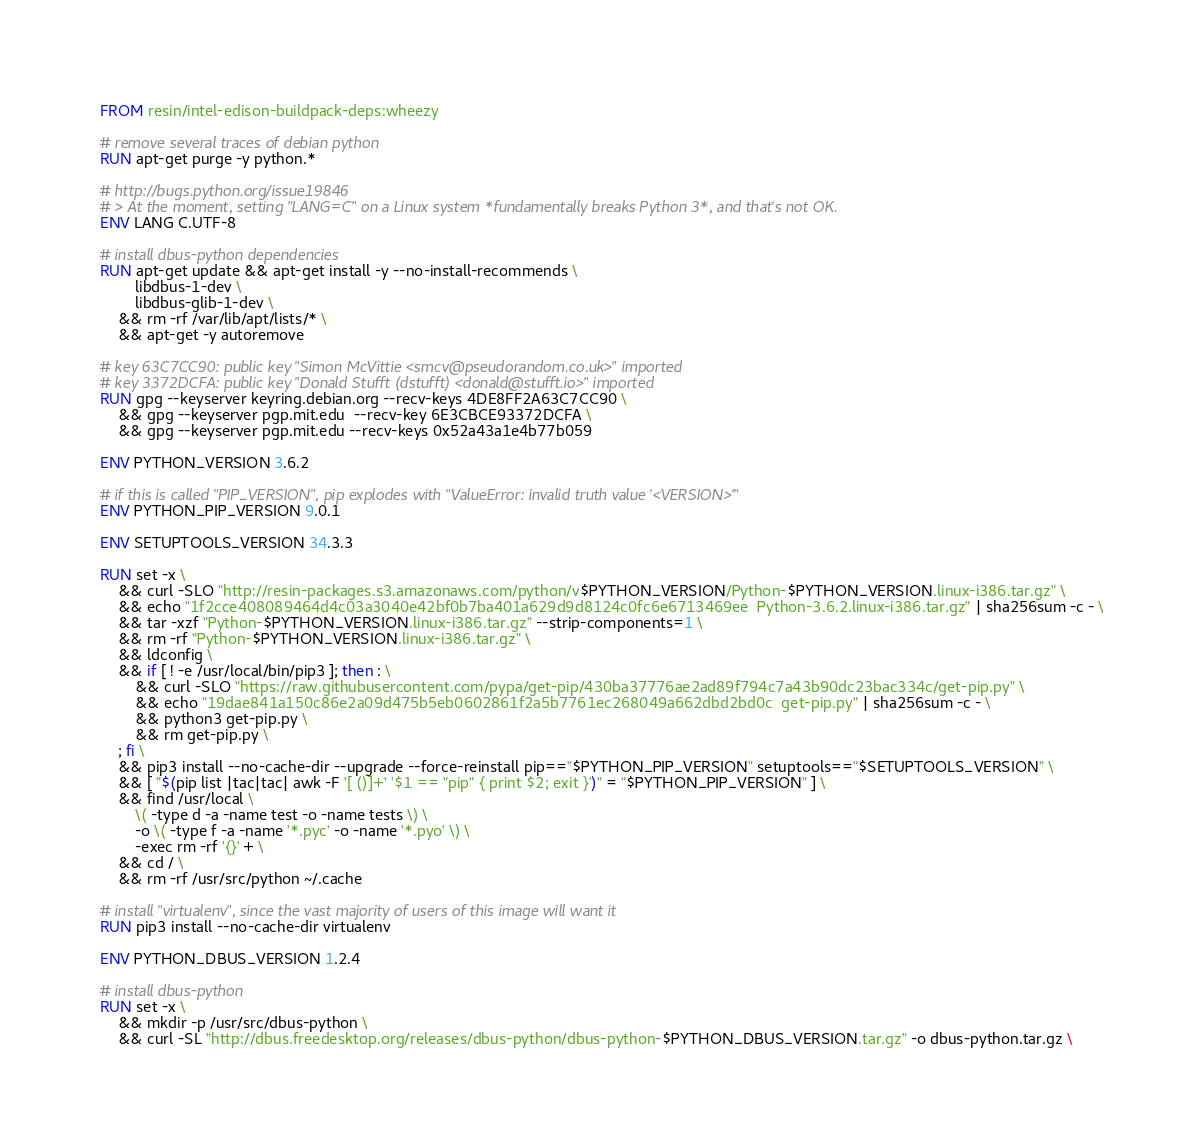<code> <loc_0><loc_0><loc_500><loc_500><_Dockerfile_>FROM resin/intel-edison-buildpack-deps:wheezy

# remove several traces of debian python
RUN apt-get purge -y python.*

# http://bugs.python.org/issue19846
# > At the moment, setting "LANG=C" on a Linux system *fundamentally breaks Python 3*, and that's not OK.
ENV LANG C.UTF-8

# install dbus-python dependencies 
RUN apt-get update && apt-get install -y --no-install-recommends \
		libdbus-1-dev \
		libdbus-glib-1-dev \
	&& rm -rf /var/lib/apt/lists/* \
	&& apt-get -y autoremove

# key 63C7CC90: public key "Simon McVittie <smcv@pseudorandom.co.uk>" imported
# key 3372DCFA: public key "Donald Stufft (dstufft) <donald@stufft.io>" imported
RUN gpg --keyserver keyring.debian.org --recv-keys 4DE8FF2A63C7CC90 \
	&& gpg --keyserver pgp.mit.edu  --recv-key 6E3CBCE93372DCFA \
	&& gpg --keyserver pgp.mit.edu --recv-keys 0x52a43a1e4b77b059

ENV PYTHON_VERSION 3.6.2

# if this is called "PIP_VERSION", pip explodes with "ValueError: invalid truth value '<VERSION>'"
ENV PYTHON_PIP_VERSION 9.0.1

ENV SETUPTOOLS_VERSION 34.3.3

RUN set -x \
	&& curl -SLO "http://resin-packages.s3.amazonaws.com/python/v$PYTHON_VERSION/Python-$PYTHON_VERSION.linux-i386.tar.gz" \
	&& echo "1f2cce408089464d4c03a3040e42bf0b7ba401a629d9d8124c0fc6e6713469ee  Python-3.6.2.linux-i386.tar.gz" | sha256sum -c - \
	&& tar -xzf "Python-$PYTHON_VERSION.linux-i386.tar.gz" --strip-components=1 \
	&& rm -rf "Python-$PYTHON_VERSION.linux-i386.tar.gz" \
	&& ldconfig \
	&& if [ ! -e /usr/local/bin/pip3 ]; then : \
		&& curl -SLO "https://raw.githubusercontent.com/pypa/get-pip/430ba37776ae2ad89f794c7a43b90dc23bac334c/get-pip.py" \
		&& echo "19dae841a150c86e2a09d475b5eb0602861f2a5b7761ec268049a662dbd2bd0c  get-pip.py" | sha256sum -c - \
		&& python3 get-pip.py \
		&& rm get-pip.py \
	; fi \
	&& pip3 install --no-cache-dir --upgrade --force-reinstall pip=="$PYTHON_PIP_VERSION" setuptools=="$SETUPTOOLS_VERSION" \
	&& [ "$(pip list |tac|tac| awk -F '[ ()]+' '$1 == "pip" { print $2; exit }')" = "$PYTHON_PIP_VERSION" ] \
	&& find /usr/local \
		\( -type d -a -name test -o -name tests \) \
		-o \( -type f -a -name '*.pyc' -o -name '*.pyo' \) \
		-exec rm -rf '{}' + \
	&& cd / \
	&& rm -rf /usr/src/python ~/.cache

# install "virtualenv", since the vast majority of users of this image will want it
RUN pip3 install --no-cache-dir virtualenv

ENV PYTHON_DBUS_VERSION 1.2.4

# install dbus-python
RUN set -x \
	&& mkdir -p /usr/src/dbus-python \
	&& curl -SL "http://dbus.freedesktop.org/releases/dbus-python/dbus-python-$PYTHON_DBUS_VERSION.tar.gz" -o dbus-python.tar.gz \</code> 